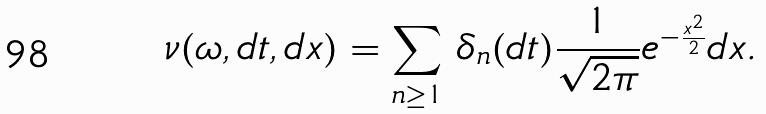<formula> <loc_0><loc_0><loc_500><loc_500>\nu ( \omega , d t , d x ) = \sum _ { n \geq 1 } \, \delta _ { n } ( d t ) \frac { 1 } { \sqrt { 2 \pi } } e ^ { - \frac { x ^ { 2 } } { 2 } } d x .</formula> 